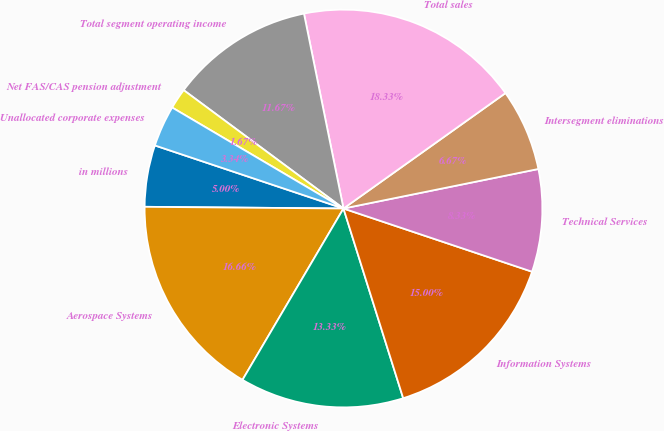Convert chart. <chart><loc_0><loc_0><loc_500><loc_500><pie_chart><fcel>in millions<fcel>Aerospace Systems<fcel>Electronic Systems<fcel>Information Systems<fcel>Technical Services<fcel>Intersegment eliminations<fcel>Total sales<fcel>Total segment operating income<fcel>Net FAS/CAS pension adjustment<fcel>Unallocated corporate expenses<nl><fcel>5.0%<fcel>16.66%<fcel>13.33%<fcel>15.0%<fcel>8.33%<fcel>6.67%<fcel>18.33%<fcel>11.67%<fcel>1.67%<fcel>3.34%<nl></chart> 